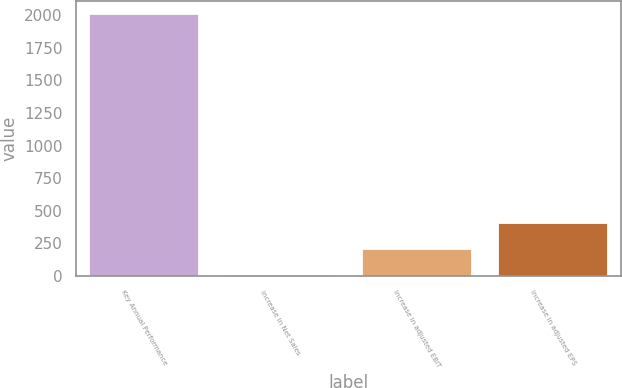Convert chart to OTSL. <chart><loc_0><loc_0><loc_500><loc_500><bar_chart><fcel>Key Annual Performance<fcel>Increase in Net Sales<fcel>Increase in adjusted EBIT<fcel>Increase in adjusted EPS<nl><fcel>2011<fcel>7.2<fcel>207.58<fcel>407.96<nl></chart> 